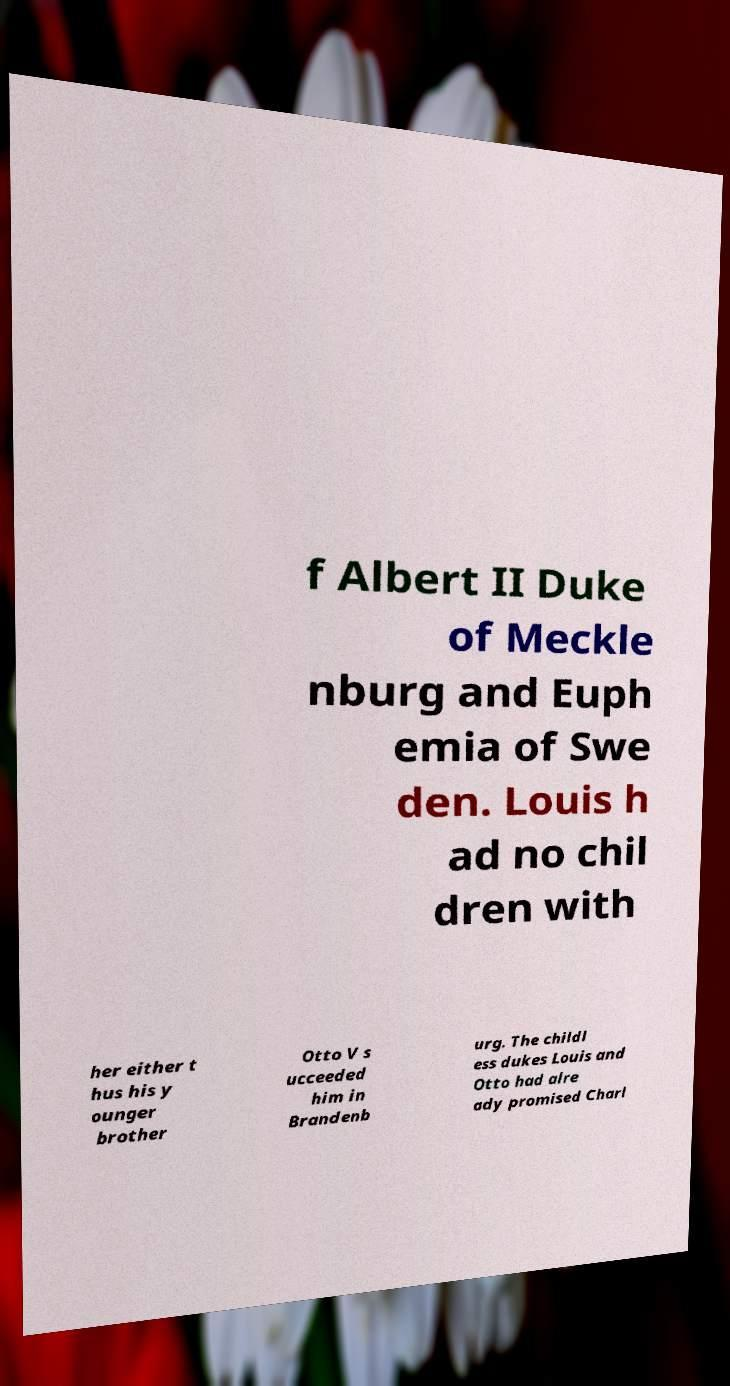Can you accurately transcribe the text from the provided image for me? f Albert II Duke of Meckle nburg and Euph emia of Swe den. Louis h ad no chil dren with her either t hus his y ounger brother Otto V s ucceeded him in Brandenb urg. The childl ess dukes Louis and Otto had alre ady promised Charl 